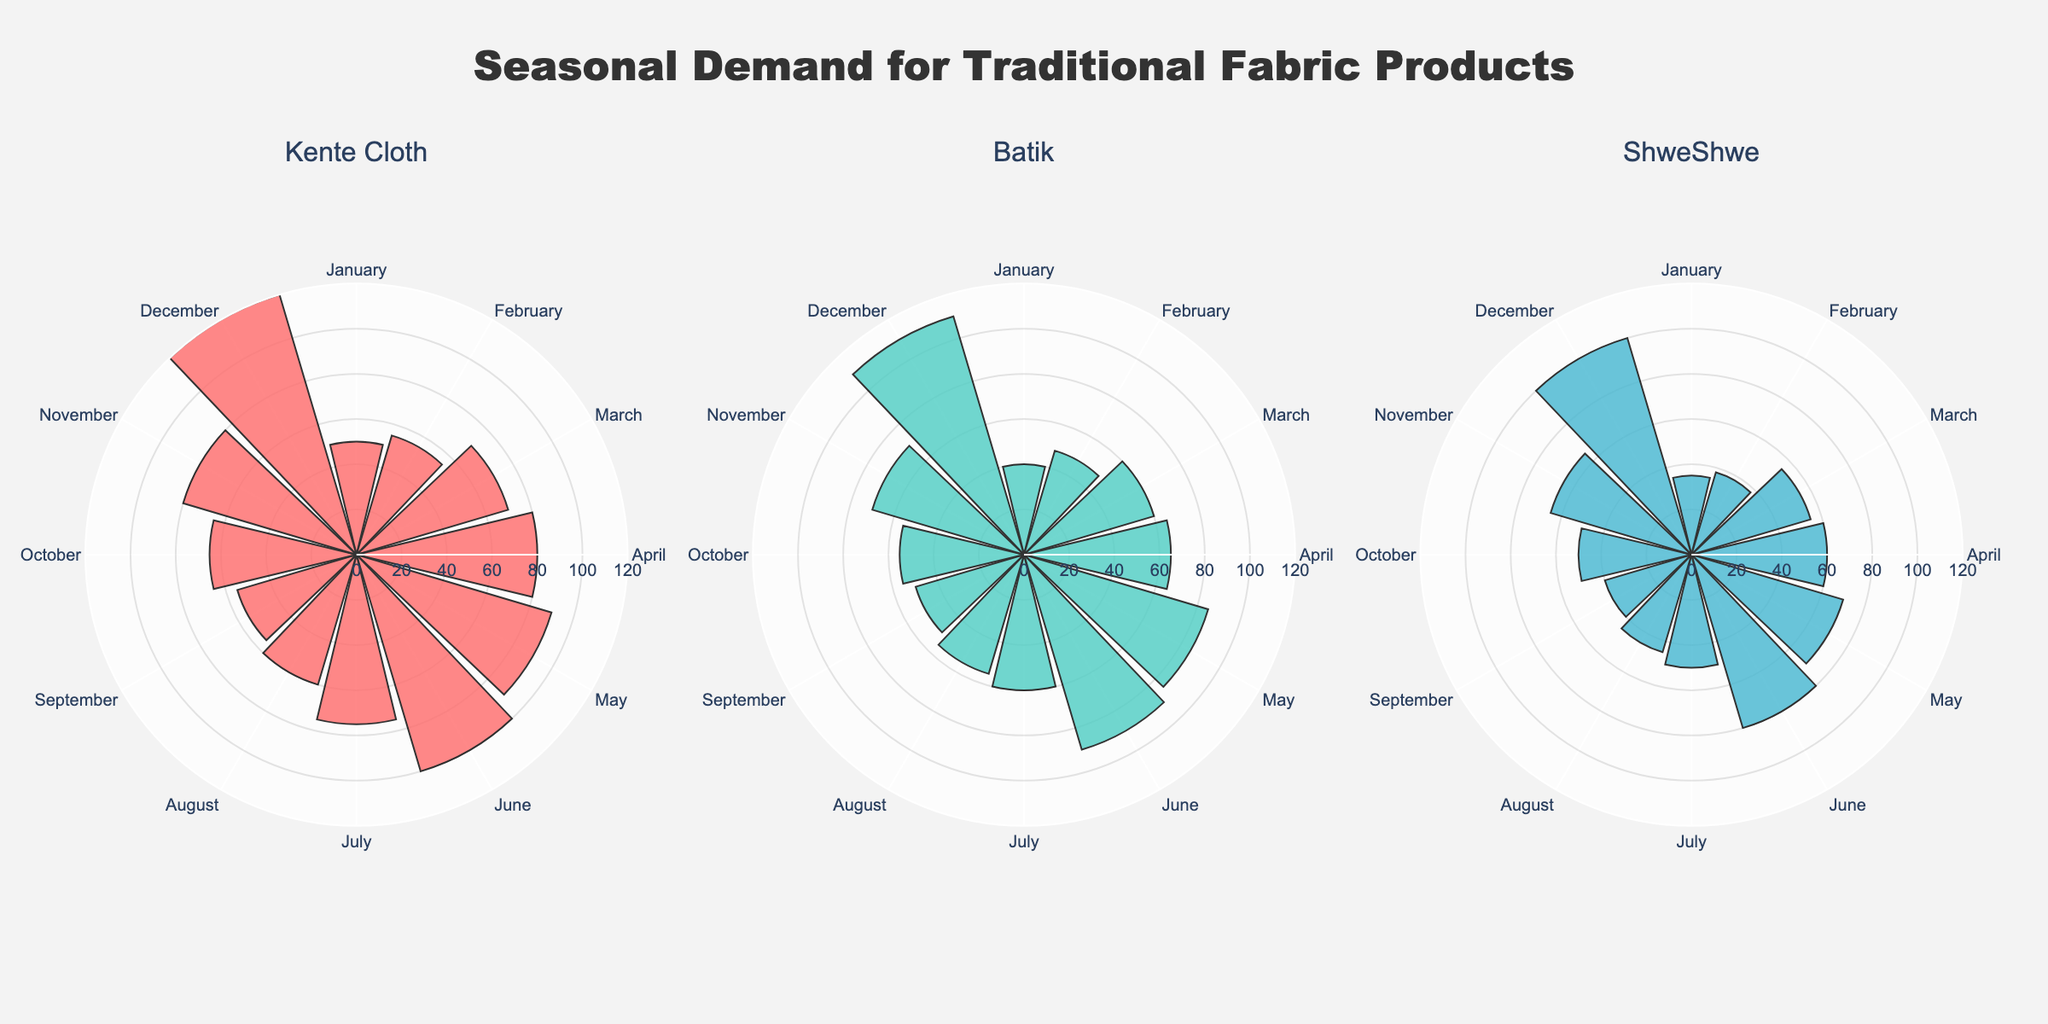What is the title of the figure? The title is typically displayed prominently at the top of the figure. Here, it is stated directly in the code snippet.
Answer: Seasonal Demand for Traditional Fabric Products Which fabric product has the highest sales in December? By examining the December sections of all subplots, we see that the Kente Cloth subplot has the longest bar, indicating the highest value.
Answer: Kente Cloth In which month does Batik have the highest sales? The longest bar in Batik's subplot corresponds to the month of December. This visual inspection identifies the peak month.
Answer: December Compare July sales of ShweShwe and Batik. Which has higher sales? Look at the July bars for both Batik and ShweShwe subplots. The Batik bar is longer, indicating higher sales.
Answer: Batik Which product has the lowest sales in August? By comparing the August sections across all subplots, the shortest bar belongs to ShweShwe.
Answer: ShweShwe What is the range of sales values shown in these charts? The smallest value is the shortest bar (ShweShwe in January, 35), and the tallest bar (Kente Cloth in December, 120) gives the highest value. Thus, the range is from 35 to 120.
Answer: 35 to 120 Which product experienced the highest variability in sales throughout the year? Kente Cloth shows the highest variability, evident through the wide range in bar lengths from around 50 to 120. Detailed analysis confirms significant differences month-to-month.
Answer: Kente Cloth How do the peak sales months for Kente Cloth and ShweShwe compare? Observing the longest bars, Kente Cloth peaks in December, while ShweShwe also peaks in December.
Answer: Both peak in December What is the cumulative sales of Batik from January to March? Sum up the Batik sales values for January (40), February (48), and March (60). The calculation is 40 + 48 + 60 = 148.
Answer: 148 In which month do all three products show above-average sales values? Average sales for each month can be visually estimated. In December, all subplots show tall bars indicating higher than average sales.
Answer: December 